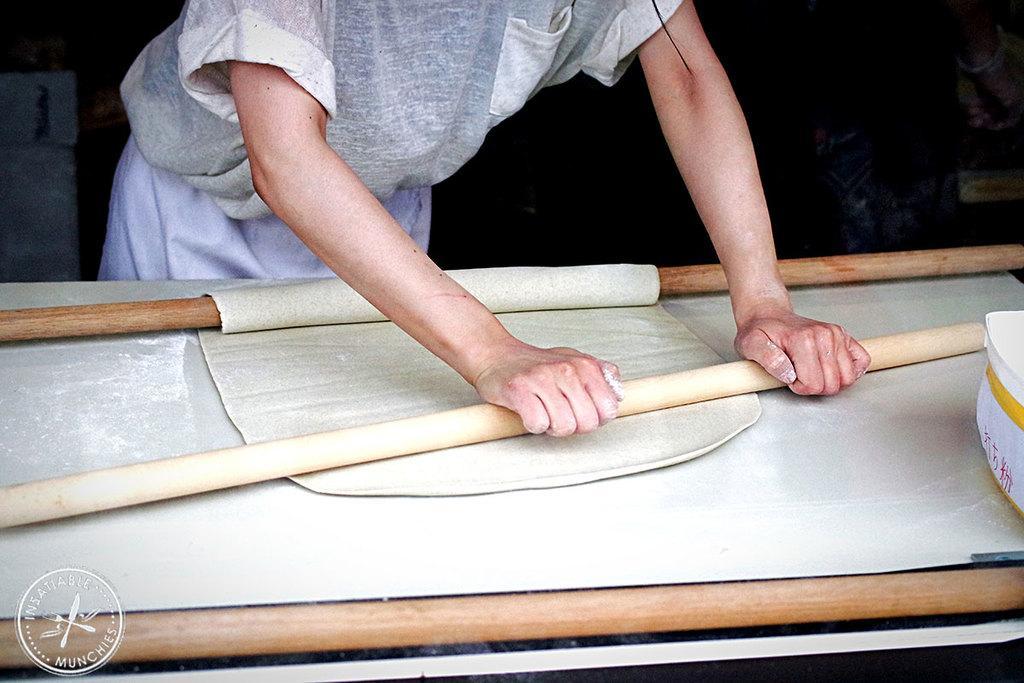Could you give a brief overview of what you see in this image? In this image we can see a man is standing, in front there is a table, a person is holding a dough with a rolling pin. 